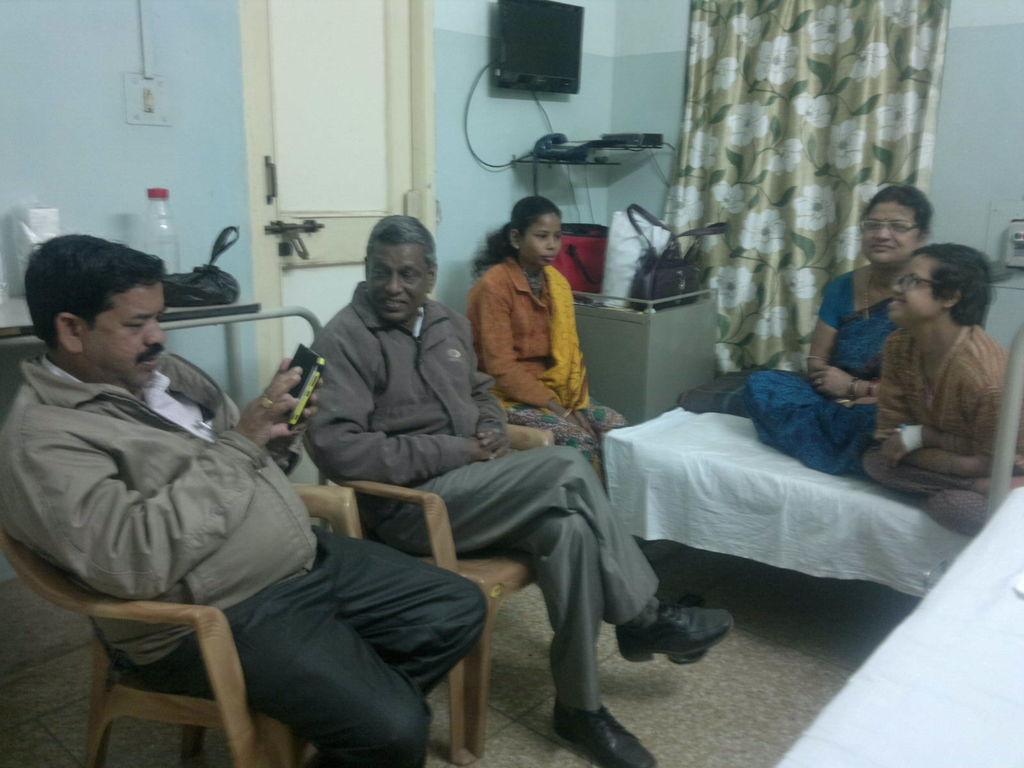Can you describe this image briefly? In this image I can see a group of people among them few are sitting on a chair and 2 are sitting on a bed. Here we have a door, a bottle and blue color wall and a TV on the wall. On the right side we have a curtain. 